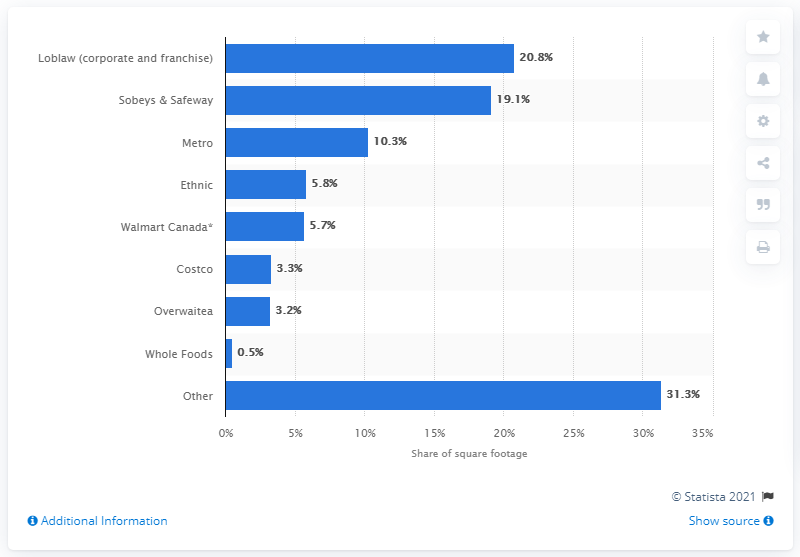List a handful of essential elements in this visual. Approximately 19.1% of the total square footage of grocery stores in Canada was occupied by Safeway and Sobeys in 2018. 